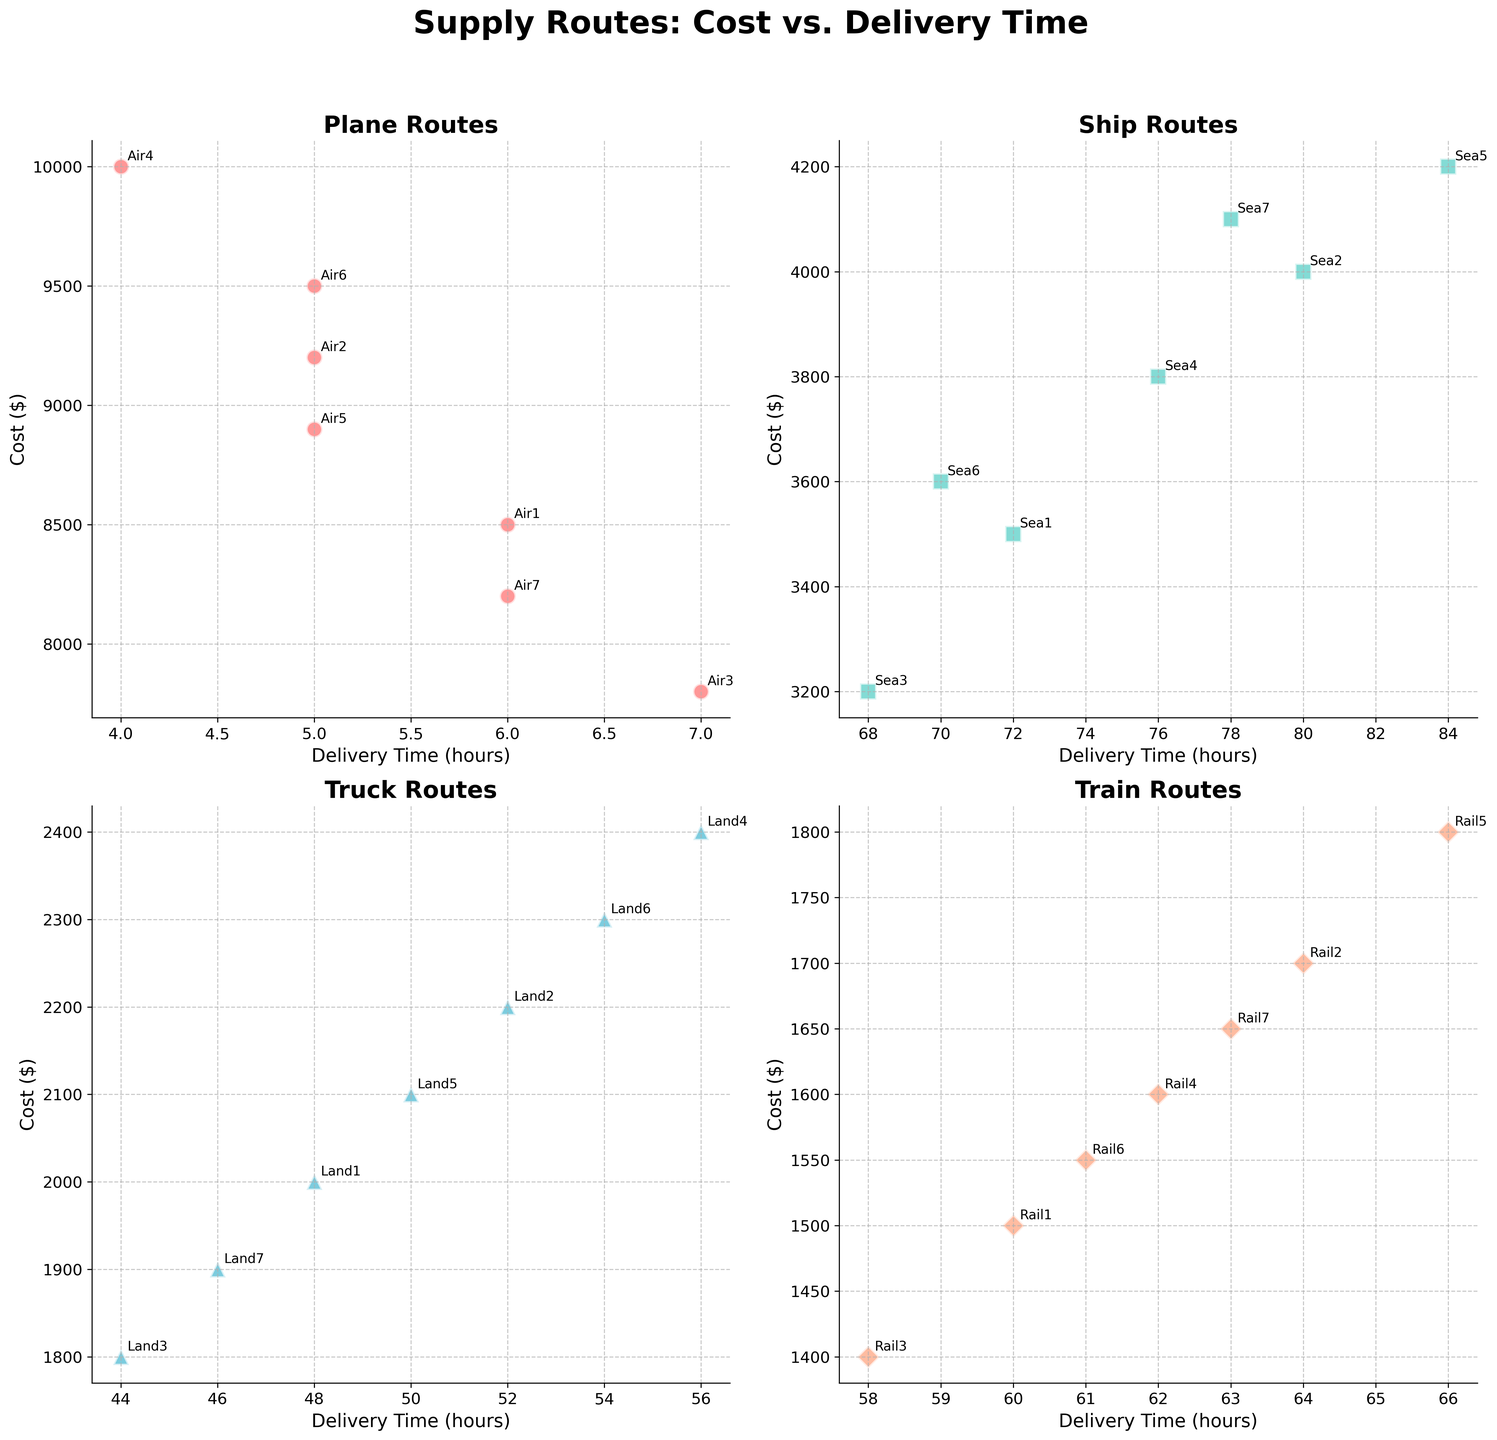What is the delivery time range for Plane routes? The delivery time for Plane routes is shown in the subplot with a title "Plane Routes". The smallest delivery time is 4 hours while the largest is 7 hours.
Answer: 4-7 hours Which transportation type shows the lowest cost and what is that cost? By examining each subplot, the lowest cost can be found in the "Train Routes" subplot, where the minimum cost is $1400.
Answer: Train, $1400 What is the difference between the highest and lowest delivery times for Ship routes? In the "Ship Routes" subplot, the highest delivery time is 84 hours and the lowest is 68 hours. The difference is 84 - 68 = 16 hours.
Answer: 16 hours Which Plane route has the highest cost? In the "Plane Routes" subplot, Air4 has the highest cost with $10,000.
Answer: Air4 How do the costs of the most expensive Plane and Ship routes compare? The highest cost for Plane routes is $10,000 (Air4), and for Ship routes, it is $4,200 (Sea5). Comparing these, 10,000 is more than 4,200.
Answer: Plane (Air4) > Ship (Sea5) What is the average cost of Truck routes? The costs for Truck routes are $2000, $2200, $1800, $2400, $2100, $2300, and $1900. The sum is 2000+2200+1800+2400+2100+2300+1900 = 14700. The number of Truck routes is 7, so the average cost is 14700 / 7 = 2100.
Answer: $2100 Which transportation type has the tightest cluster of delivery times? By visually inspecting the subplots, Plane routes have deliveries mainly grouped between 4 to 7 hours, whereas other types have a wider range of delivery times.
Answer: Plane routes What is the cost range of Train routes? In the "Train Routes" subplot, the lowest cost is $1400 and the highest is $1800. The difference is 1800 - 1400 = $400.
Answer: $400 Which route (considering all types) offers the quickest delivery time? The quickest delivery time can be found by comparing the shortest delivery times in all subplots, which is 4 hours for Plane route Air4.
Answer: Air4 Which transportation type has the most routes with costs above $5000? In the subplots, Plane routes have seven different routes (Air1, Air2, Air3, Air4, Air5, Air6, Air7) with costs above $5000.
Answer: Planes 